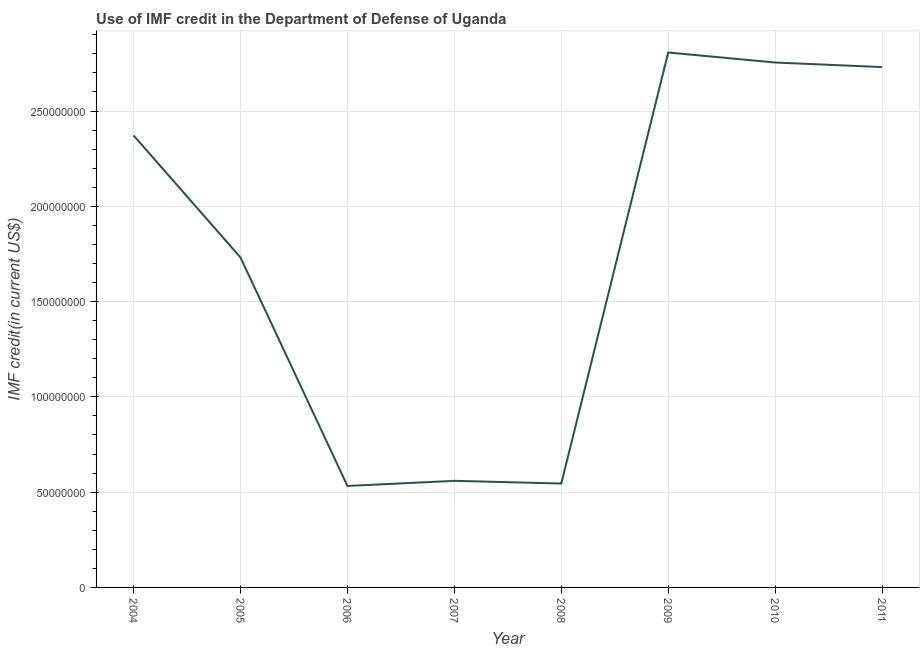What is the use of imf credit in dod in 2004?
Provide a succinct answer. 2.37e+08. Across all years, what is the maximum use of imf credit in dod?
Provide a succinct answer. 2.81e+08. Across all years, what is the minimum use of imf credit in dod?
Provide a succinct answer. 5.32e+07. What is the sum of the use of imf credit in dod?
Provide a succinct answer. 1.40e+09. What is the difference between the use of imf credit in dod in 2004 and 2005?
Your answer should be very brief. 6.41e+07. What is the average use of imf credit in dod per year?
Provide a short and direct response. 1.75e+08. What is the median use of imf credit in dod?
Offer a terse response. 2.05e+08. In how many years, is the use of imf credit in dod greater than 170000000 US$?
Your answer should be compact. 5. What is the ratio of the use of imf credit in dod in 2006 to that in 2010?
Ensure brevity in your answer.  0.19. Is the use of imf credit in dod in 2010 less than that in 2011?
Offer a very short reply. No. What is the difference between the highest and the second highest use of imf credit in dod?
Your answer should be very brief. 5.26e+06. Is the sum of the use of imf credit in dod in 2004 and 2005 greater than the maximum use of imf credit in dod across all years?
Your answer should be very brief. Yes. What is the difference between the highest and the lowest use of imf credit in dod?
Offer a very short reply. 2.27e+08. In how many years, is the use of imf credit in dod greater than the average use of imf credit in dod taken over all years?
Your response must be concise. 4. Does the use of imf credit in dod monotonically increase over the years?
Make the answer very short. No. How many years are there in the graph?
Provide a short and direct response. 8. What is the difference between two consecutive major ticks on the Y-axis?
Your response must be concise. 5.00e+07. Are the values on the major ticks of Y-axis written in scientific E-notation?
Make the answer very short. No. Does the graph contain any zero values?
Give a very brief answer. No. Does the graph contain grids?
Your response must be concise. Yes. What is the title of the graph?
Keep it short and to the point. Use of IMF credit in the Department of Defense of Uganda. What is the label or title of the Y-axis?
Provide a succinct answer. IMF credit(in current US$). What is the IMF credit(in current US$) of 2004?
Your answer should be compact. 2.37e+08. What is the IMF credit(in current US$) of 2005?
Give a very brief answer. 1.73e+08. What is the IMF credit(in current US$) of 2006?
Ensure brevity in your answer.  5.32e+07. What is the IMF credit(in current US$) of 2007?
Ensure brevity in your answer.  5.59e+07. What is the IMF credit(in current US$) in 2008?
Your answer should be compact. 5.45e+07. What is the IMF credit(in current US$) of 2009?
Ensure brevity in your answer.  2.81e+08. What is the IMF credit(in current US$) of 2010?
Provide a short and direct response. 2.75e+08. What is the IMF credit(in current US$) of 2011?
Your answer should be very brief. 2.73e+08. What is the difference between the IMF credit(in current US$) in 2004 and 2005?
Make the answer very short. 6.41e+07. What is the difference between the IMF credit(in current US$) in 2004 and 2006?
Give a very brief answer. 1.84e+08. What is the difference between the IMF credit(in current US$) in 2004 and 2007?
Ensure brevity in your answer.  1.81e+08. What is the difference between the IMF credit(in current US$) in 2004 and 2008?
Keep it short and to the point. 1.83e+08. What is the difference between the IMF credit(in current US$) in 2004 and 2009?
Your response must be concise. -4.35e+07. What is the difference between the IMF credit(in current US$) in 2004 and 2010?
Your response must be concise. -3.83e+07. What is the difference between the IMF credit(in current US$) in 2004 and 2011?
Give a very brief answer. -3.59e+07. What is the difference between the IMF credit(in current US$) in 2005 and 2006?
Your answer should be very brief. 1.20e+08. What is the difference between the IMF credit(in current US$) in 2005 and 2007?
Ensure brevity in your answer.  1.17e+08. What is the difference between the IMF credit(in current US$) in 2005 and 2008?
Keep it short and to the point. 1.19e+08. What is the difference between the IMF credit(in current US$) in 2005 and 2009?
Keep it short and to the point. -1.08e+08. What is the difference between the IMF credit(in current US$) in 2005 and 2010?
Offer a very short reply. -1.02e+08. What is the difference between the IMF credit(in current US$) in 2005 and 2011?
Give a very brief answer. -9.99e+07. What is the difference between the IMF credit(in current US$) in 2006 and 2007?
Your answer should be compact. -2.69e+06. What is the difference between the IMF credit(in current US$) in 2006 and 2008?
Offer a terse response. -1.27e+06. What is the difference between the IMF credit(in current US$) in 2006 and 2009?
Your answer should be very brief. -2.27e+08. What is the difference between the IMF credit(in current US$) in 2006 and 2010?
Your answer should be compact. -2.22e+08. What is the difference between the IMF credit(in current US$) in 2006 and 2011?
Offer a terse response. -2.20e+08. What is the difference between the IMF credit(in current US$) in 2007 and 2008?
Make the answer very short. 1.42e+06. What is the difference between the IMF credit(in current US$) in 2007 and 2009?
Your answer should be very brief. -2.25e+08. What is the difference between the IMF credit(in current US$) in 2007 and 2010?
Your response must be concise. -2.20e+08. What is the difference between the IMF credit(in current US$) in 2007 and 2011?
Make the answer very short. -2.17e+08. What is the difference between the IMF credit(in current US$) in 2008 and 2009?
Your response must be concise. -2.26e+08. What is the difference between the IMF credit(in current US$) in 2008 and 2010?
Offer a very short reply. -2.21e+08. What is the difference between the IMF credit(in current US$) in 2008 and 2011?
Give a very brief answer. -2.19e+08. What is the difference between the IMF credit(in current US$) in 2009 and 2010?
Ensure brevity in your answer.  5.26e+06. What is the difference between the IMF credit(in current US$) in 2009 and 2011?
Your response must be concise. 7.65e+06. What is the difference between the IMF credit(in current US$) in 2010 and 2011?
Offer a very short reply. 2.39e+06. What is the ratio of the IMF credit(in current US$) in 2004 to that in 2005?
Your response must be concise. 1.37. What is the ratio of the IMF credit(in current US$) in 2004 to that in 2006?
Make the answer very short. 4.45. What is the ratio of the IMF credit(in current US$) in 2004 to that in 2007?
Your response must be concise. 4.24. What is the ratio of the IMF credit(in current US$) in 2004 to that in 2008?
Provide a short and direct response. 4.35. What is the ratio of the IMF credit(in current US$) in 2004 to that in 2009?
Your response must be concise. 0.84. What is the ratio of the IMF credit(in current US$) in 2004 to that in 2010?
Offer a terse response. 0.86. What is the ratio of the IMF credit(in current US$) in 2004 to that in 2011?
Ensure brevity in your answer.  0.87. What is the ratio of the IMF credit(in current US$) in 2005 to that in 2006?
Your answer should be very brief. 3.25. What is the ratio of the IMF credit(in current US$) in 2005 to that in 2007?
Your answer should be very brief. 3.1. What is the ratio of the IMF credit(in current US$) in 2005 to that in 2008?
Your response must be concise. 3.17. What is the ratio of the IMF credit(in current US$) in 2005 to that in 2009?
Your answer should be very brief. 0.62. What is the ratio of the IMF credit(in current US$) in 2005 to that in 2010?
Provide a succinct answer. 0.63. What is the ratio of the IMF credit(in current US$) in 2005 to that in 2011?
Provide a short and direct response. 0.63. What is the ratio of the IMF credit(in current US$) in 2006 to that in 2007?
Your answer should be compact. 0.95. What is the ratio of the IMF credit(in current US$) in 2006 to that in 2009?
Provide a succinct answer. 0.19. What is the ratio of the IMF credit(in current US$) in 2006 to that in 2010?
Provide a succinct answer. 0.19. What is the ratio of the IMF credit(in current US$) in 2006 to that in 2011?
Provide a succinct answer. 0.2. What is the ratio of the IMF credit(in current US$) in 2007 to that in 2008?
Your answer should be compact. 1.03. What is the ratio of the IMF credit(in current US$) in 2007 to that in 2009?
Offer a very short reply. 0.2. What is the ratio of the IMF credit(in current US$) in 2007 to that in 2010?
Make the answer very short. 0.2. What is the ratio of the IMF credit(in current US$) in 2007 to that in 2011?
Your answer should be compact. 0.2. What is the ratio of the IMF credit(in current US$) in 2008 to that in 2009?
Your response must be concise. 0.19. What is the ratio of the IMF credit(in current US$) in 2008 to that in 2010?
Offer a very short reply. 0.2. What is the ratio of the IMF credit(in current US$) in 2009 to that in 2011?
Your answer should be very brief. 1.03. What is the ratio of the IMF credit(in current US$) in 2010 to that in 2011?
Give a very brief answer. 1.01. 